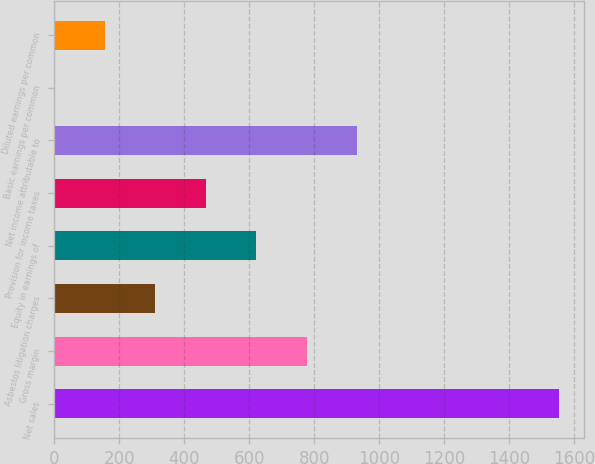Convert chart to OTSL. <chart><loc_0><loc_0><loc_500><loc_500><bar_chart><fcel>Net sales<fcel>Gross margin<fcel>Asbestos litigation charges<fcel>Equity in earnings of<fcel>Provision for income taxes<fcel>Net income attributable to<fcel>Basic earnings per common<fcel>Diluted earnings per common<nl><fcel>1553<fcel>776.77<fcel>311.02<fcel>621.52<fcel>466.27<fcel>932.02<fcel>0.52<fcel>155.77<nl></chart> 